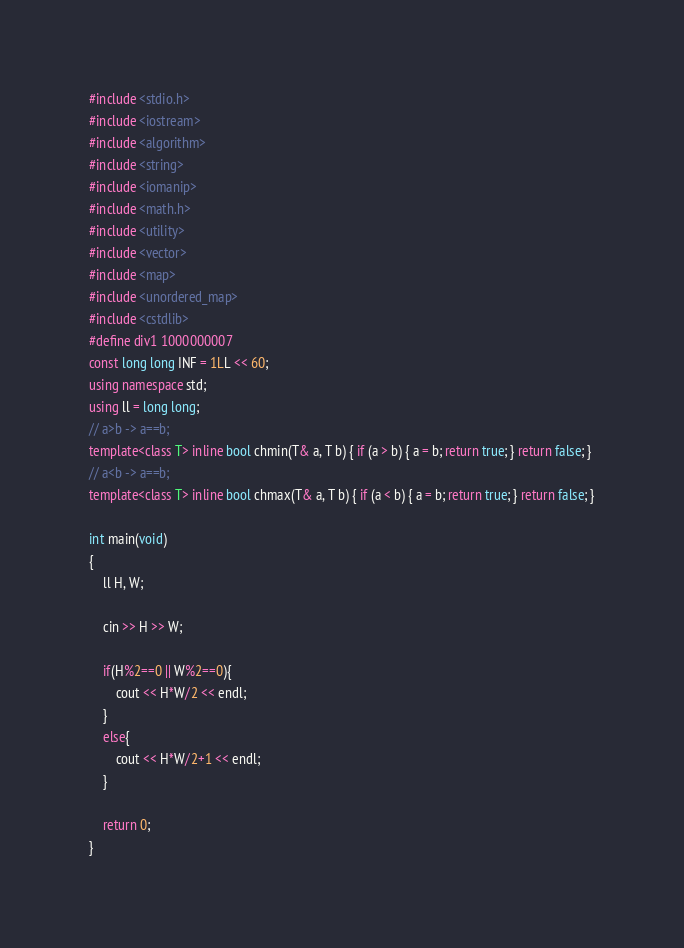<code> <loc_0><loc_0><loc_500><loc_500><_C++_>#include <stdio.h>
#include <iostream>
#include <algorithm>
#include <string>
#include <iomanip>
#include <math.h>
#include <utility>
#include <vector>
#include <map>
#include <unordered_map>
#include <cstdlib>
#define div1 1000000007
const long long INF = 1LL << 60;
using namespace std;
using ll = long long;
// a>b -> a==b;
template<class T> inline bool chmin(T& a, T b) { if (a > b) { a = b; return true; } return false; }
// a<b -> a==b;
template<class T> inline bool chmax(T& a, T b) { if (a < b) { a = b; return true; } return false; }

int main(void)
{
    ll H, W;

    cin >> H >> W;

    if(H%2==0 || W%2==0){
        cout << H*W/2 << endl;
    }
    else{
        cout << H*W/2+1 << endl;
    }

    return 0;
}</code> 